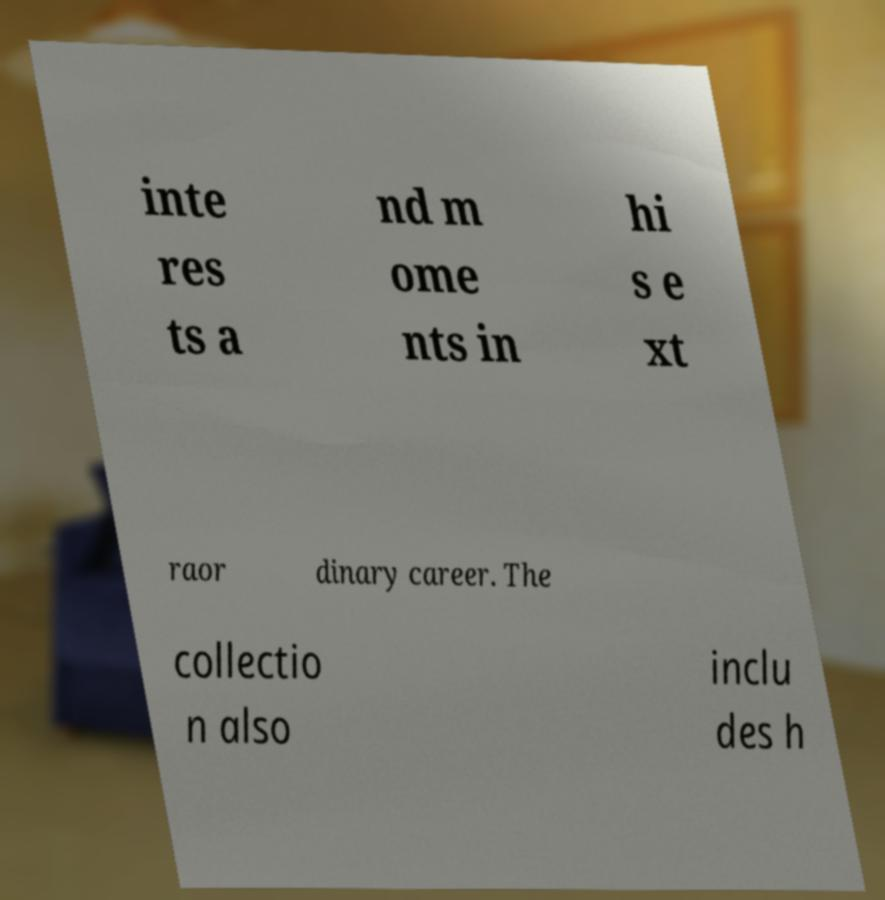Please identify and transcribe the text found in this image. inte res ts a nd m ome nts in hi s e xt raor dinary career. The collectio n also inclu des h 